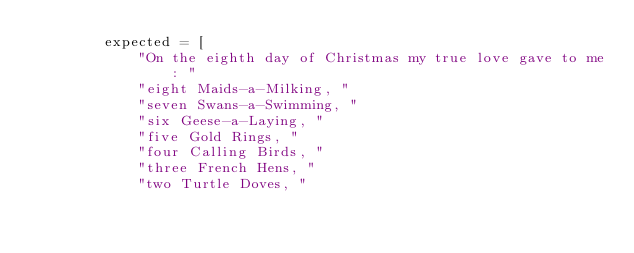Convert code to text. <code><loc_0><loc_0><loc_500><loc_500><_Python_>        expected = [
            "On the eighth day of Christmas my true love gave to me: "
            "eight Maids-a-Milking, "
            "seven Swans-a-Swimming, "
            "six Geese-a-Laying, "
            "five Gold Rings, "
            "four Calling Birds, "
            "three French Hens, "
            "two Turtle Doves, "</code> 